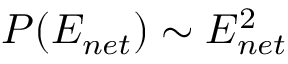<formula> <loc_0><loc_0><loc_500><loc_500>P ( E _ { n e t } ) \sim E _ { n e t } ^ { 2 }</formula> 